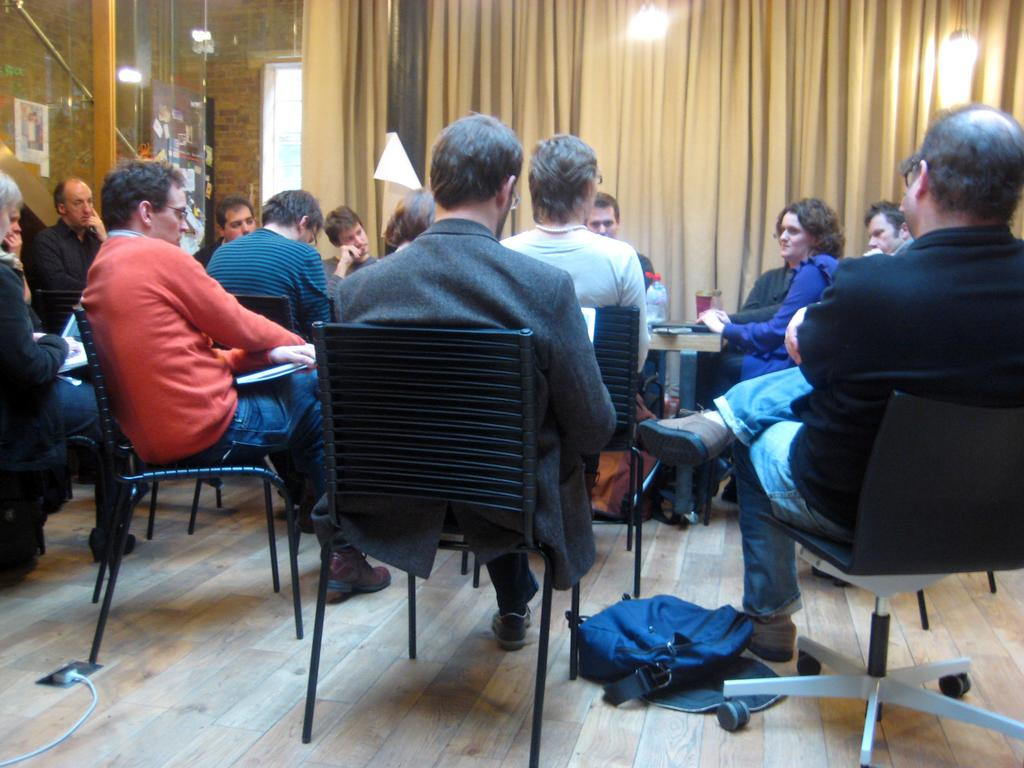How many people are in the image? There is a group of people in the image. What are the people doing in the image? The people are sitting on chairs and engaged in a discussion. What can be seen in the background of the image? There is a curtain visible in the image. What is providing illumination in the image? There are lights present in the image. Are any of the people wearing masks in the image? There is no mention of masks in the image, so we cannot determine if any of the people are wearing them. 